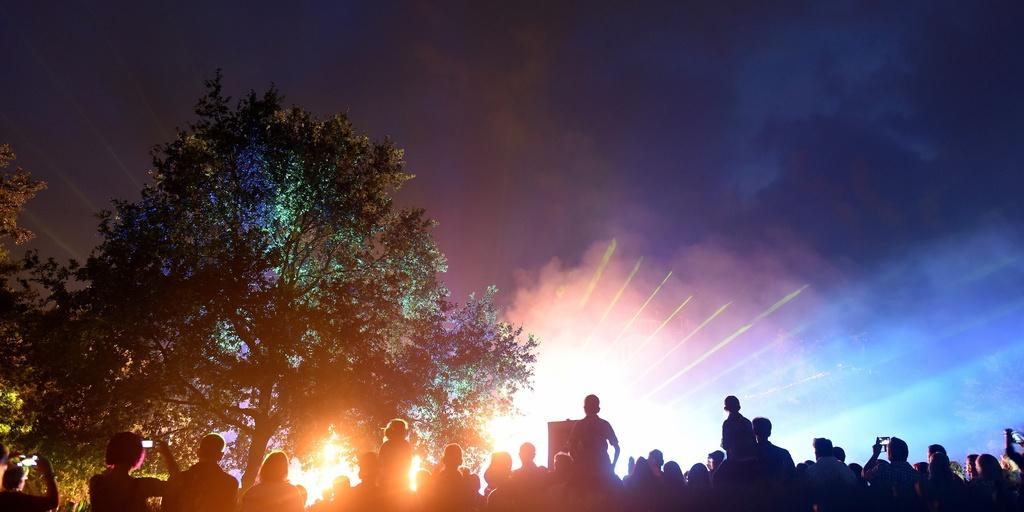How many people are in the image? There is a group of people in the image, but the exact number cannot be determined from the provided facts. What type of natural elements can be seen in the image? There are trees and the sky visible in the image. What is the source of light in the image? The presence of fire in the image suggests that it is the source of light. What else can be seen in the image besides the people and trees? There are objects in the image, but their specific nature cannot be determined from the provided facts. Is there a basketball court visible in the image? There is no mention of a basketball court in the provided facts, so it cannot be determined if one is present in the image. 